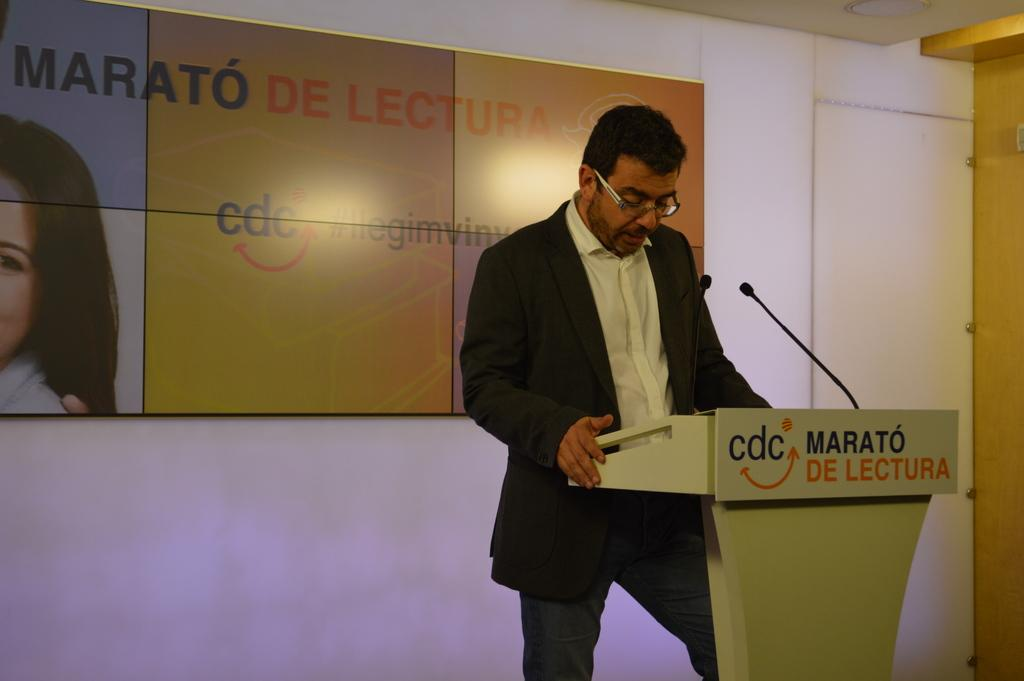What is the man in the image doing? The man is standing in front of a podium. What can be seen on the podium? There are two microphones on the podium. What is located in the background of the image? There is a board in the background of the image. What is written or displayed on the board? There is text visible on the board. What type of farm animals can be seen grazing on the podium in the image? There are no farm animals present in the image; the man is standing in front of a podium with two microphones. 